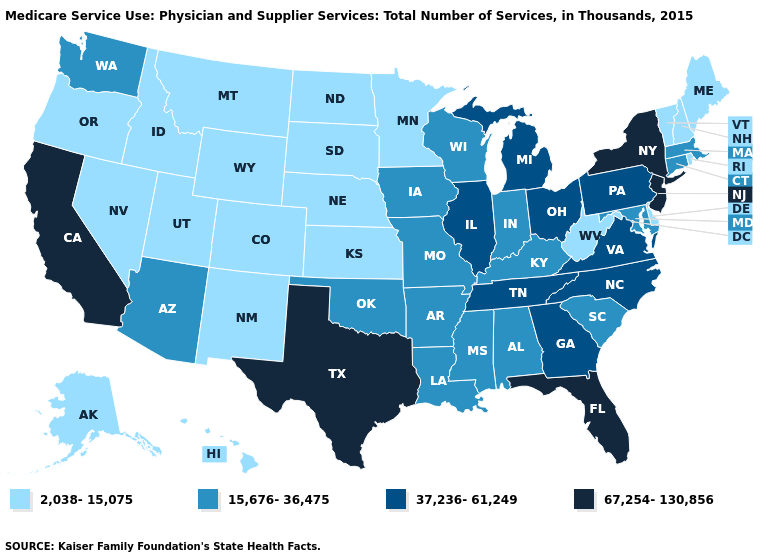Which states have the lowest value in the USA?
Be succinct. Alaska, Colorado, Delaware, Hawaii, Idaho, Kansas, Maine, Minnesota, Montana, Nebraska, Nevada, New Hampshire, New Mexico, North Dakota, Oregon, Rhode Island, South Dakota, Utah, Vermont, West Virginia, Wyoming. Name the states that have a value in the range 15,676-36,475?
Be succinct. Alabama, Arizona, Arkansas, Connecticut, Indiana, Iowa, Kentucky, Louisiana, Maryland, Massachusetts, Mississippi, Missouri, Oklahoma, South Carolina, Washington, Wisconsin. What is the highest value in the West ?
Short answer required. 67,254-130,856. Does Colorado have the lowest value in the USA?
Be succinct. Yes. Name the states that have a value in the range 67,254-130,856?
Give a very brief answer. California, Florida, New Jersey, New York, Texas. Does Kansas have the lowest value in the MidWest?
Keep it brief. Yes. What is the value of Wyoming?
Answer briefly. 2,038-15,075. Name the states that have a value in the range 67,254-130,856?
Short answer required. California, Florida, New Jersey, New York, Texas. What is the lowest value in the USA?
Write a very short answer. 2,038-15,075. How many symbols are there in the legend?
Be succinct. 4. What is the value of Colorado?
Keep it brief. 2,038-15,075. What is the value of Iowa?
Quick response, please. 15,676-36,475. Which states have the lowest value in the MidWest?
Answer briefly. Kansas, Minnesota, Nebraska, North Dakota, South Dakota. Name the states that have a value in the range 2,038-15,075?
Quick response, please. Alaska, Colorado, Delaware, Hawaii, Idaho, Kansas, Maine, Minnesota, Montana, Nebraska, Nevada, New Hampshire, New Mexico, North Dakota, Oregon, Rhode Island, South Dakota, Utah, Vermont, West Virginia, Wyoming. 